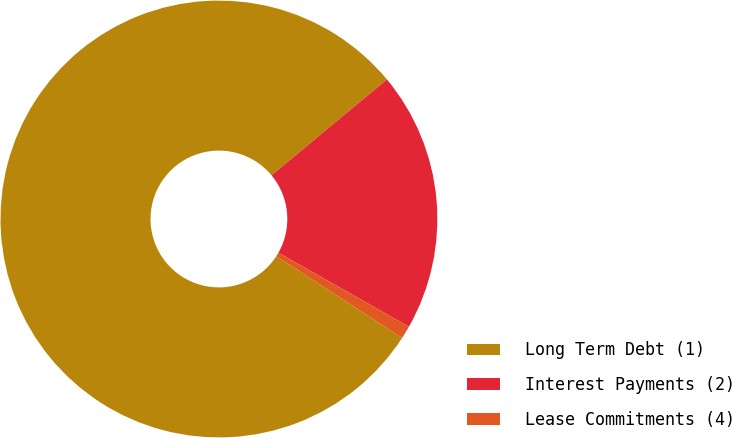<chart> <loc_0><loc_0><loc_500><loc_500><pie_chart><fcel>Long Term Debt (1)<fcel>Interest Payments (2)<fcel>Lease Commitments (4)<nl><fcel>79.81%<fcel>19.24%<fcel>0.95%<nl></chart> 